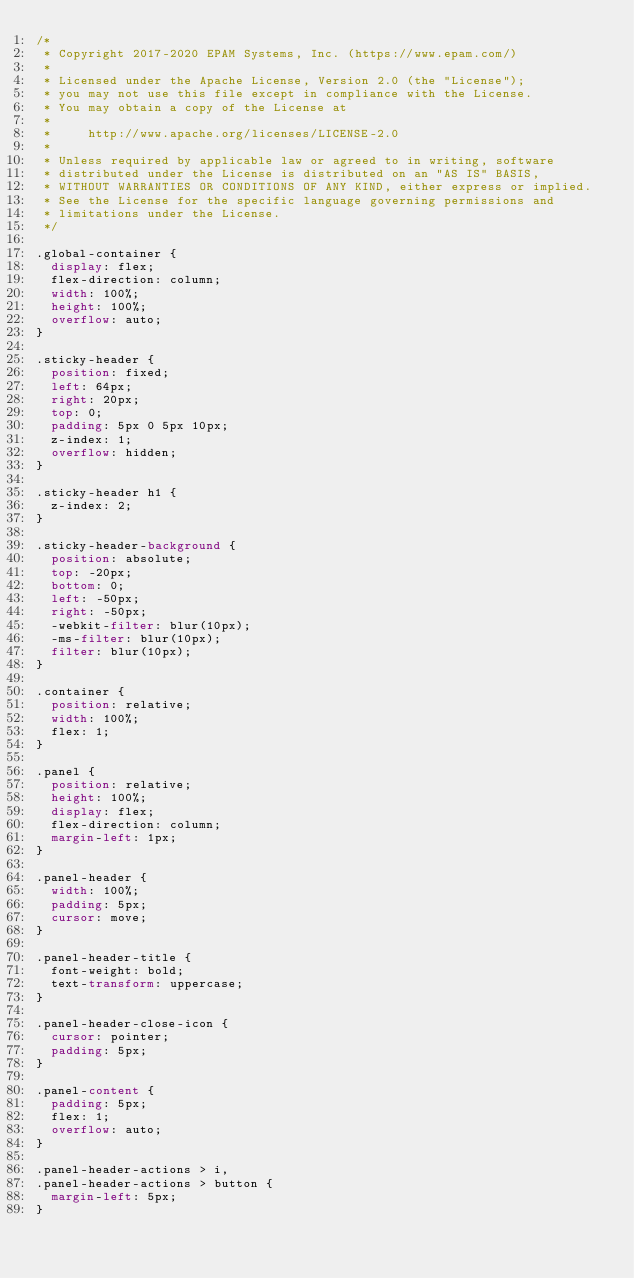Convert code to text. <code><loc_0><loc_0><loc_500><loc_500><_CSS_>/*
 * Copyright 2017-2020 EPAM Systems, Inc. (https://www.epam.com/)
 *
 * Licensed under the Apache License, Version 2.0 (the "License");
 * you may not use this file except in compliance with the License.
 * You may obtain a copy of the License at
 *
 *     http://www.apache.org/licenses/LICENSE-2.0
 *
 * Unless required by applicable law or agreed to in writing, software
 * distributed under the License is distributed on an "AS IS" BASIS,
 * WITHOUT WARRANTIES OR CONDITIONS OF ANY KIND, either express or implied.
 * See the License for the specific language governing permissions and
 * limitations under the License.
 */

.global-container {
  display: flex;
  flex-direction: column;
  width: 100%;
  height: 100%;
  overflow: auto;
}

.sticky-header {
  position: fixed;
  left: 64px;
  right: 20px;
  top: 0;
  padding: 5px 0 5px 10px;
  z-index: 1;
  overflow: hidden;
}

.sticky-header h1 {
  z-index: 2;
}

.sticky-header-background {
  position: absolute;
  top: -20px;
  bottom: 0;
  left: -50px;
  right: -50px;
  -webkit-filter: blur(10px);
  -ms-filter: blur(10px);
  filter: blur(10px);
}

.container {
  position: relative;
  width: 100%;
  flex: 1;
}

.panel {
  position: relative;
  height: 100%;
  display: flex;
  flex-direction: column;
  margin-left: 1px;
}

.panel-header {
  width: 100%;
  padding: 5px;
  cursor: move;
}

.panel-header-title {
  font-weight: bold;
  text-transform: uppercase;
}

.panel-header-close-icon {
  cursor: pointer;
  padding: 5px;
}

.panel-content {
  padding: 5px;
  flex: 1;
  overflow: auto;
}

.panel-header-actions > i,
.panel-header-actions > button {
  margin-left: 5px;
}
</code> 